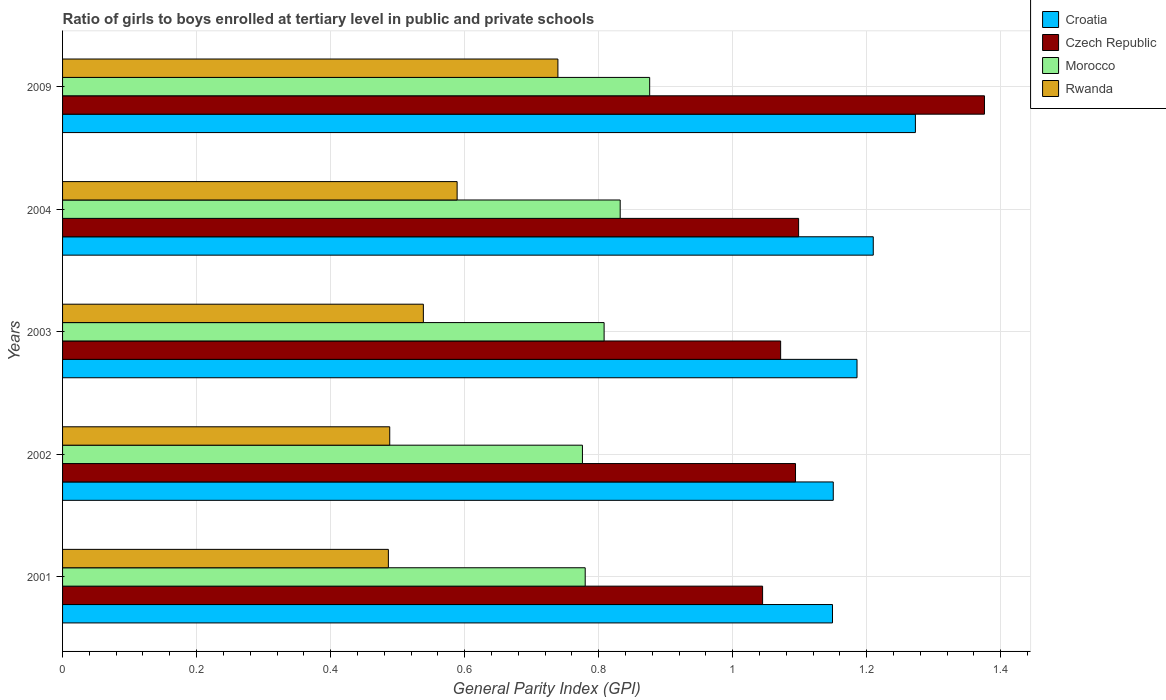How many groups of bars are there?
Offer a very short reply. 5. Are the number of bars on each tick of the Y-axis equal?
Provide a succinct answer. Yes. How many bars are there on the 4th tick from the top?
Your response must be concise. 4. How many bars are there on the 2nd tick from the bottom?
Provide a succinct answer. 4. What is the general parity index in Morocco in 2004?
Your answer should be very brief. 0.83. Across all years, what is the maximum general parity index in Czech Republic?
Give a very brief answer. 1.38. Across all years, what is the minimum general parity index in Croatia?
Make the answer very short. 1.15. What is the total general parity index in Morocco in the graph?
Provide a short and direct response. 4.07. What is the difference between the general parity index in Rwanda in 2003 and that in 2004?
Your answer should be compact. -0.05. What is the difference between the general parity index in Rwanda in 2001 and the general parity index in Croatia in 2003?
Your answer should be very brief. -0.7. What is the average general parity index in Morocco per year?
Make the answer very short. 0.81. In the year 2004, what is the difference between the general parity index in Morocco and general parity index in Croatia?
Make the answer very short. -0.38. What is the ratio of the general parity index in Czech Republic in 2003 to that in 2004?
Offer a very short reply. 0.98. What is the difference between the highest and the second highest general parity index in Morocco?
Your response must be concise. 0.04. What is the difference between the highest and the lowest general parity index in Morocco?
Your response must be concise. 0.1. Is it the case that in every year, the sum of the general parity index in Czech Republic and general parity index in Morocco is greater than the sum of general parity index in Croatia and general parity index in Rwanda?
Offer a very short reply. No. What does the 2nd bar from the top in 2009 represents?
Make the answer very short. Morocco. What does the 3rd bar from the bottom in 2003 represents?
Offer a very short reply. Morocco. How many bars are there?
Ensure brevity in your answer.  20. Are all the bars in the graph horizontal?
Offer a very short reply. Yes. What is the difference between two consecutive major ticks on the X-axis?
Offer a terse response. 0.2. Are the values on the major ticks of X-axis written in scientific E-notation?
Your answer should be compact. No. Does the graph contain any zero values?
Your response must be concise. No. Does the graph contain grids?
Provide a succinct answer. Yes. How many legend labels are there?
Give a very brief answer. 4. What is the title of the graph?
Offer a very short reply. Ratio of girls to boys enrolled at tertiary level in public and private schools. Does "Qatar" appear as one of the legend labels in the graph?
Provide a short and direct response. No. What is the label or title of the X-axis?
Your response must be concise. General Parity Index (GPI). What is the General Parity Index (GPI) in Croatia in 2001?
Provide a succinct answer. 1.15. What is the General Parity Index (GPI) in Czech Republic in 2001?
Provide a succinct answer. 1.04. What is the General Parity Index (GPI) in Morocco in 2001?
Your answer should be compact. 0.78. What is the General Parity Index (GPI) of Rwanda in 2001?
Your response must be concise. 0.49. What is the General Parity Index (GPI) of Croatia in 2002?
Offer a very short reply. 1.15. What is the General Parity Index (GPI) of Czech Republic in 2002?
Your answer should be compact. 1.09. What is the General Parity Index (GPI) of Morocco in 2002?
Offer a very short reply. 0.78. What is the General Parity Index (GPI) in Rwanda in 2002?
Your response must be concise. 0.49. What is the General Parity Index (GPI) in Croatia in 2003?
Ensure brevity in your answer.  1.19. What is the General Parity Index (GPI) in Czech Republic in 2003?
Offer a terse response. 1.07. What is the General Parity Index (GPI) of Morocco in 2003?
Your answer should be very brief. 0.81. What is the General Parity Index (GPI) in Rwanda in 2003?
Offer a very short reply. 0.54. What is the General Parity Index (GPI) in Croatia in 2004?
Your answer should be compact. 1.21. What is the General Parity Index (GPI) of Czech Republic in 2004?
Your answer should be compact. 1.1. What is the General Parity Index (GPI) of Morocco in 2004?
Provide a short and direct response. 0.83. What is the General Parity Index (GPI) in Rwanda in 2004?
Ensure brevity in your answer.  0.59. What is the General Parity Index (GPI) in Croatia in 2009?
Provide a succinct answer. 1.27. What is the General Parity Index (GPI) in Czech Republic in 2009?
Provide a succinct answer. 1.38. What is the General Parity Index (GPI) of Morocco in 2009?
Your answer should be compact. 0.88. What is the General Parity Index (GPI) in Rwanda in 2009?
Your response must be concise. 0.74. Across all years, what is the maximum General Parity Index (GPI) of Croatia?
Provide a short and direct response. 1.27. Across all years, what is the maximum General Parity Index (GPI) of Czech Republic?
Provide a short and direct response. 1.38. Across all years, what is the maximum General Parity Index (GPI) in Morocco?
Your response must be concise. 0.88. Across all years, what is the maximum General Parity Index (GPI) of Rwanda?
Provide a short and direct response. 0.74. Across all years, what is the minimum General Parity Index (GPI) in Croatia?
Your answer should be very brief. 1.15. Across all years, what is the minimum General Parity Index (GPI) in Czech Republic?
Ensure brevity in your answer.  1.04. Across all years, what is the minimum General Parity Index (GPI) of Morocco?
Your answer should be compact. 0.78. Across all years, what is the minimum General Parity Index (GPI) of Rwanda?
Offer a terse response. 0.49. What is the total General Parity Index (GPI) of Croatia in the graph?
Your answer should be compact. 5.97. What is the total General Parity Index (GPI) of Czech Republic in the graph?
Offer a terse response. 5.68. What is the total General Parity Index (GPI) of Morocco in the graph?
Ensure brevity in your answer.  4.07. What is the total General Parity Index (GPI) in Rwanda in the graph?
Your answer should be compact. 2.84. What is the difference between the General Parity Index (GPI) in Croatia in 2001 and that in 2002?
Your answer should be very brief. -0. What is the difference between the General Parity Index (GPI) in Czech Republic in 2001 and that in 2002?
Keep it short and to the point. -0.05. What is the difference between the General Parity Index (GPI) of Morocco in 2001 and that in 2002?
Ensure brevity in your answer.  0. What is the difference between the General Parity Index (GPI) in Rwanda in 2001 and that in 2002?
Provide a short and direct response. -0. What is the difference between the General Parity Index (GPI) of Croatia in 2001 and that in 2003?
Offer a terse response. -0.04. What is the difference between the General Parity Index (GPI) in Czech Republic in 2001 and that in 2003?
Make the answer very short. -0.03. What is the difference between the General Parity Index (GPI) of Morocco in 2001 and that in 2003?
Your answer should be compact. -0.03. What is the difference between the General Parity Index (GPI) of Rwanda in 2001 and that in 2003?
Ensure brevity in your answer.  -0.05. What is the difference between the General Parity Index (GPI) of Croatia in 2001 and that in 2004?
Your answer should be compact. -0.06. What is the difference between the General Parity Index (GPI) of Czech Republic in 2001 and that in 2004?
Ensure brevity in your answer.  -0.05. What is the difference between the General Parity Index (GPI) of Morocco in 2001 and that in 2004?
Offer a very short reply. -0.05. What is the difference between the General Parity Index (GPI) in Rwanda in 2001 and that in 2004?
Offer a very short reply. -0.1. What is the difference between the General Parity Index (GPI) in Croatia in 2001 and that in 2009?
Your answer should be very brief. -0.12. What is the difference between the General Parity Index (GPI) in Czech Republic in 2001 and that in 2009?
Ensure brevity in your answer.  -0.33. What is the difference between the General Parity Index (GPI) of Morocco in 2001 and that in 2009?
Offer a terse response. -0.1. What is the difference between the General Parity Index (GPI) in Rwanda in 2001 and that in 2009?
Keep it short and to the point. -0.25. What is the difference between the General Parity Index (GPI) of Croatia in 2002 and that in 2003?
Provide a short and direct response. -0.04. What is the difference between the General Parity Index (GPI) of Czech Republic in 2002 and that in 2003?
Give a very brief answer. 0.02. What is the difference between the General Parity Index (GPI) of Morocco in 2002 and that in 2003?
Your answer should be compact. -0.03. What is the difference between the General Parity Index (GPI) of Rwanda in 2002 and that in 2003?
Keep it short and to the point. -0.05. What is the difference between the General Parity Index (GPI) in Croatia in 2002 and that in 2004?
Ensure brevity in your answer.  -0.06. What is the difference between the General Parity Index (GPI) of Czech Republic in 2002 and that in 2004?
Provide a short and direct response. -0. What is the difference between the General Parity Index (GPI) in Morocco in 2002 and that in 2004?
Offer a terse response. -0.06. What is the difference between the General Parity Index (GPI) in Rwanda in 2002 and that in 2004?
Make the answer very short. -0.1. What is the difference between the General Parity Index (GPI) in Croatia in 2002 and that in 2009?
Make the answer very short. -0.12. What is the difference between the General Parity Index (GPI) of Czech Republic in 2002 and that in 2009?
Offer a very short reply. -0.28. What is the difference between the General Parity Index (GPI) in Morocco in 2002 and that in 2009?
Your answer should be very brief. -0.1. What is the difference between the General Parity Index (GPI) in Rwanda in 2002 and that in 2009?
Provide a succinct answer. -0.25. What is the difference between the General Parity Index (GPI) of Croatia in 2003 and that in 2004?
Ensure brevity in your answer.  -0.02. What is the difference between the General Parity Index (GPI) of Czech Republic in 2003 and that in 2004?
Provide a short and direct response. -0.03. What is the difference between the General Parity Index (GPI) in Morocco in 2003 and that in 2004?
Offer a terse response. -0.02. What is the difference between the General Parity Index (GPI) in Rwanda in 2003 and that in 2004?
Keep it short and to the point. -0.05. What is the difference between the General Parity Index (GPI) in Croatia in 2003 and that in 2009?
Give a very brief answer. -0.09. What is the difference between the General Parity Index (GPI) of Czech Republic in 2003 and that in 2009?
Your answer should be compact. -0.3. What is the difference between the General Parity Index (GPI) of Morocco in 2003 and that in 2009?
Your answer should be compact. -0.07. What is the difference between the General Parity Index (GPI) in Rwanda in 2003 and that in 2009?
Your answer should be compact. -0.2. What is the difference between the General Parity Index (GPI) in Croatia in 2004 and that in 2009?
Offer a very short reply. -0.06. What is the difference between the General Parity Index (GPI) in Czech Republic in 2004 and that in 2009?
Keep it short and to the point. -0.28. What is the difference between the General Parity Index (GPI) of Morocco in 2004 and that in 2009?
Your answer should be very brief. -0.04. What is the difference between the General Parity Index (GPI) in Rwanda in 2004 and that in 2009?
Provide a succinct answer. -0.15. What is the difference between the General Parity Index (GPI) in Croatia in 2001 and the General Parity Index (GPI) in Czech Republic in 2002?
Your response must be concise. 0.06. What is the difference between the General Parity Index (GPI) in Croatia in 2001 and the General Parity Index (GPI) in Morocco in 2002?
Offer a terse response. 0.37. What is the difference between the General Parity Index (GPI) in Croatia in 2001 and the General Parity Index (GPI) in Rwanda in 2002?
Keep it short and to the point. 0.66. What is the difference between the General Parity Index (GPI) of Czech Republic in 2001 and the General Parity Index (GPI) of Morocco in 2002?
Ensure brevity in your answer.  0.27. What is the difference between the General Parity Index (GPI) of Czech Republic in 2001 and the General Parity Index (GPI) of Rwanda in 2002?
Your answer should be very brief. 0.56. What is the difference between the General Parity Index (GPI) of Morocco in 2001 and the General Parity Index (GPI) of Rwanda in 2002?
Give a very brief answer. 0.29. What is the difference between the General Parity Index (GPI) of Croatia in 2001 and the General Parity Index (GPI) of Czech Republic in 2003?
Make the answer very short. 0.08. What is the difference between the General Parity Index (GPI) of Croatia in 2001 and the General Parity Index (GPI) of Morocco in 2003?
Provide a short and direct response. 0.34. What is the difference between the General Parity Index (GPI) in Croatia in 2001 and the General Parity Index (GPI) in Rwanda in 2003?
Keep it short and to the point. 0.61. What is the difference between the General Parity Index (GPI) of Czech Republic in 2001 and the General Parity Index (GPI) of Morocco in 2003?
Offer a very short reply. 0.24. What is the difference between the General Parity Index (GPI) of Czech Republic in 2001 and the General Parity Index (GPI) of Rwanda in 2003?
Offer a terse response. 0.51. What is the difference between the General Parity Index (GPI) of Morocco in 2001 and the General Parity Index (GPI) of Rwanda in 2003?
Your response must be concise. 0.24. What is the difference between the General Parity Index (GPI) in Croatia in 2001 and the General Parity Index (GPI) in Czech Republic in 2004?
Your answer should be very brief. 0.05. What is the difference between the General Parity Index (GPI) in Croatia in 2001 and the General Parity Index (GPI) in Morocco in 2004?
Give a very brief answer. 0.32. What is the difference between the General Parity Index (GPI) of Croatia in 2001 and the General Parity Index (GPI) of Rwanda in 2004?
Your response must be concise. 0.56. What is the difference between the General Parity Index (GPI) in Czech Republic in 2001 and the General Parity Index (GPI) in Morocco in 2004?
Provide a short and direct response. 0.21. What is the difference between the General Parity Index (GPI) in Czech Republic in 2001 and the General Parity Index (GPI) in Rwanda in 2004?
Your answer should be very brief. 0.46. What is the difference between the General Parity Index (GPI) in Morocco in 2001 and the General Parity Index (GPI) in Rwanda in 2004?
Provide a short and direct response. 0.19. What is the difference between the General Parity Index (GPI) of Croatia in 2001 and the General Parity Index (GPI) of Czech Republic in 2009?
Make the answer very short. -0.23. What is the difference between the General Parity Index (GPI) in Croatia in 2001 and the General Parity Index (GPI) in Morocco in 2009?
Provide a succinct answer. 0.27. What is the difference between the General Parity Index (GPI) of Croatia in 2001 and the General Parity Index (GPI) of Rwanda in 2009?
Give a very brief answer. 0.41. What is the difference between the General Parity Index (GPI) in Czech Republic in 2001 and the General Parity Index (GPI) in Morocco in 2009?
Keep it short and to the point. 0.17. What is the difference between the General Parity Index (GPI) in Czech Republic in 2001 and the General Parity Index (GPI) in Rwanda in 2009?
Ensure brevity in your answer.  0.31. What is the difference between the General Parity Index (GPI) in Morocco in 2001 and the General Parity Index (GPI) in Rwanda in 2009?
Offer a terse response. 0.04. What is the difference between the General Parity Index (GPI) in Croatia in 2002 and the General Parity Index (GPI) in Czech Republic in 2003?
Provide a short and direct response. 0.08. What is the difference between the General Parity Index (GPI) in Croatia in 2002 and the General Parity Index (GPI) in Morocco in 2003?
Your answer should be very brief. 0.34. What is the difference between the General Parity Index (GPI) of Croatia in 2002 and the General Parity Index (GPI) of Rwanda in 2003?
Your answer should be very brief. 0.61. What is the difference between the General Parity Index (GPI) of Czech Republic in 2002 and the General Parity Index (GPI) of Morocco in 2003?
Your answer should be compact. 0.29. What is the difference between the General Parity Index (GPI) of Czech Republic in 2002 and the General Parity Index (GPI) of Rwanda in 2003?
Provide a short and direct response. 0.56. What is the difference between the General Parity Index (GPI) of Morocco in 2002 and the General Parity Index (GPI) of Rwanda in 2003?
Make the answer very short. 0.24. What is the difference between the General Parity Index (GPI) in Croatia in 2002 and the General Parity Index (GPI) in Czech Republic in 2004?
Ensure brevity in your answer.  0.05. What is the difference between the General Parity Index (GPI) in Croatia in 2002 and the General Parity Index (GPI) in Morocco in 2004?
Your answer should be compact. 0.32. What is the difference between the General Parity Index (GPI) in Croatia in 2002 and the General Parity Index (GPI) in Rwanda in 2004?
Ensure brevity in your answer.  0.56. What is the difference between the General Parity Index (GPI) of Czech Republic in 2002 and the General Parity Index (GPI) of Morocco in 2004?
Provide a succinct answer. 0.26. What is the difference between the General Parity Index (GPI) in Czech Republic in 2002 and the General Parity Index (GPI) in Rwanda in 2004?
Provide a succinct answer. 0.51. What is the difference between the General Parity Index (GPI) in Morocco in 2002 and the General Parity Index (GPI) in Rwanda in 2004?
Make the answer very short. 0.19. What is the difference between the General Parity Index (GPI) in Croatia in 2002 and the General Parity Index (GPI) in Czech Republic in 2009?
Offer a terse response. -0.23. What is the difference between the General Parity Index (GPI) of Croatia in 2002 and the General Parity Index (GPI) of Morocco in 2009?
Offer a very short reply. 0.27. What is the difference between the General Parity Index (GPI) in Croatia in 2002 and the General Parity Index (GPI) in Rwanda in 2009?
Provide a short and direct response. 0.41. What is the difference between the General Parity Index (GPI) of Czech Republic in 2002 and the General Parity Index (GPI) of Morocco in 2009?
Your answer should be very brief. 0.22. What is the difference between the General Parity Index (GPI) of Czech Republic in 2002 and the General Parity Index (GPI) of Rwanda in 2009?
Your response must be concise. 0.35. What is the difference between the General Parity Index (GPI) of Morocco in 2002 and the General Parity Index (GPI) of Rwanda in 2009?
Give a very brief answer. 0.04. What is the difference between the General Parity Index (GPI) in Croatia in 2003 and the General Parity Index (GPI) in Czech Republic in 2004?
Make the answer very short. 0.09. What is the difference between the General Parity Index (GPI) of Croatia in 2003 and the General Parity Index (GPI) of Morocco in 2004?
Provide a succinct answer. 0.35. What is the difference between the General Parity Index (GPI) of Croatia in 2003 and the General Parity Index (GPI) of Rwanda in 2004?
Your answer should be compact. 0.6. What is the difference between the General Parity Index (GPI) in Czech Republic in 2003 and the General Parity Index (GPI) in Morocco in 2004?
Keep it short and to the point. 0.24. What is the difference between the General Parity Index (GPI) in Czech Republic in 2003 and the General Parity Index (GPI) in Rwanda in 2004?
Provide a succinct answer. 0.48. What is the difference between the General Parity Index (GPI) of Morocco in 2003 and the General Parity Index (GPI) of Rwanda in 2004?
Your answer should be compact. 0.22. What is the difference between the General Parity Index (GPI) of Croatia in 2003 and the General Parity Index (GPI) of Czech Republic in 2009?
Ensure brevity in your answer.  -0.19. What is the difference between the General Parity Index (GPI) in Croatia in 2003 and the General Parity Index (GPI) in Morocco in 2009?
Your answer should be very brief. 0.31. What is the difference between the General Parity Index (GPI) of Croatia in 2003 and the General Parity Index (GPI) of Rwanda in 2009?
Offer a very short reply. 0.45. What is the difference between the General Parity Index (GPI) in Czech Republic in 2003 and the General Parity Index (GPI) in Morocco in 2009?
Your answer should be very brief. 0.2. What is the difference between the General Parity Index (GPI) of Czech Republic in 2003 and the General Parity Index (GPI) of Rwanda in 2009?
Provide a succinct answer. 0.33. What is the difference between the General Parity Index (GPI) in Morocco in 2003 and the General Parity Index (GPI) in Rwanda in 2009?
Offer a terse response. 0.07. What is the difference between the General Parity Index (GPI) in Croatia in 2004 and the General Parity Index (GPI) in Czech Republic in 2009?
Give a very brief answer. -0.17. What is the difference between the General Parity Index (GPI) of Croatia in 2004 and the General Parity Index (GPI) of Morocco in 2009?
Your answer should be very brief. 0.33. What is the difference between the General Parity Index (GPI) of Croatia in 2004 and the General Parity Index (GPI) of Rwanda in 2009?
Your response must be concise. 0.47. What is the difference between the General Parity Index (GPI) in Czech Republic in 2004 and the General Parity Index (GPI) in Morocco in 2009?
Ensure brevity in your answer.  0.22. What is the difference between the General Parity Index (GPI) of Czech Republic in 2004 and the General Parity Index (GPI) of Rwanda in 2009?
Provide a succinct answer. 0.36. What is the difference between the General Parity Index (GPI) of Morocco in 2004 and the General Parity Index (GPI) of Rwanda in 2009?
Make the answer very short. 0.09. What is the average General Parity Index (GPI) of Croatia per year?
Keep it short and to the point. 1.19. What is the average General Parity Index (GPI) in Czech Republic per year?
Your answer should be very brief. 1.14. What is the average General Parity Index (GPI) of Morocco per year?
Provide a short and direct response. 0.81. What is the average General Parity Index (GPI) in Rwanda per year?
Offer a very short reply. 0.57. In the year 2001, what is the difference between the General Parity Index (GPI) in Croatia and General Parity Index (GPI) in Czech Republic?
Offer a terse response. 0.1. In the year 2001, what is the difference between the General Parity Index (GPI) of Croatia and General Parity Index (GPI) of Morocco?
Ensure brevity in your answer.  0.37. In the year 2001, what is the difference between the General Parity Index (GPI) in Croatia and General Parity Index (GPI) in Rwanda?
Keep it short and to the point. 0.66. In the year 2001, what is the difference between the General Parity Index (GPI) in Czech Republic and General Parity Index (GPI) in Morocco?
Provide a succinct answer. 0.26. In the year 2001, what is the difference between the General Parity Index (GPI) in Czech Republic and General Parity Index (GPI) in Rwanda?
Your response must be concise. 0.56. In the year 2001, what is the difference between the General Parity Index (GPI) in Morocco and General Parity Index (GPI) in Rwanda?
Your answer should be very brief. 0.29. In the year 2002, what is the difference between the General Parity Index (GPI) in Croatia and General Parity Index (GPI) in Czech Republic?
Provide a short and direct response. 0.06. In the year 2002, what is the difference between the General Parity Index (GPI) of Croatia and General Parity Index (GPI) of Morocco?
Your answer should be very brief. 0.37. In the year 2002, what is the difference between the General Parity Index (GPI) of Croatia and General Parity Index (GPI) of Rwanda?
Your answer should be very brief. 0.66. In the year 2002, what is the difference between the General Parity Index (GPI) of Czech Republic and General Parity Index (GPI) of Morocco?
Provide a short and direct response. 0.32. In the year 2002, what is the difference between the General Parity Index (GPI) of Czech Republic and General Parity Index (GPI) of Rwanda?
Give a very brief answer. 0.61. In the year 2002, what is the difference between the General Parity Index (GPI) of Morocco and General Parity Index (GPI) of Rwanda?
Provide a short and direct response. 0.29. In the year 2003, what is the difference between the General Parity Index (GPI) in Croatia and General Parity Index (GPI) in Czech Republic?
Ensure brevity in your answer.  0.11. In the year 2003, what is the difference between the General Parity Index (GPI) of Croatia and General Parity Index (GPI) of Morocco?
Keep it short and to the point. 0.38. In the year 2003, what is the difference between the General Parity Index (GPI) in Croatia and General Parity Index (GPI) in Rwanda?
Keep it short and to the point. 0.65. In the year 2003, what is the difference between the General Parity Index (GPI) in Czech Republic and General Parity Index (GPI) in Morocco?
Provide a short and direct response. 0.26. In the year 2003, what is the difference between the General Parity Index (GPI) of Czech Republic and General Parity Index (GPI) of Rwanda?
Offer a very short reply. 0.53. In the year 2003, what is the difference between the General Parity Index (GPI) of Morocco and General Parity Index (GPI) of Rwanda?
Offer a very short reply. 0.27. In the year 2004, what is the difference between the General Parity Index (GPI) in Croatia and General Parity Index (GPI) in Czech Republic?
Make the answer very short. 0.11. In the year 2004, what is the difference between the General Parity Index (GPI) of Croatia and General Parity Index (GPI) of Morocco?
Offer a very short reply. 0.38. In the year 2004, what is the difference between the General Parity Index (GPI) in Croatia and General Parity Index (GPI) in Rwanda?
Provide a succinct answer. 0.62. In the year 2004, what is the difference between the General Parity Index (GPI) of Czech Republic and General Parity Index (GPI) of Morocco?
Your answer should be compact. 0.27. In the year 2004, what is the difference between the General Parity Index (GPI) of Czech Republic and General Parity Index (GPI) of Rwanda?
Provide a short and direct response. 0.51. In the year 2004, what is the difference between the General Parity Index (GPI) of Morocco and General Parity Index (GPI) of Rwanda?
Your response must be concise. 0.24. In the year 2009, what is the difference between the General Parity Index (GPI) in Croatia and General Parity Index (GPI) in Czech Republic?
Provide a succinct answer. -0.1. In the year 2009, what is the difference between the General Parity Index (GPI) of Croatia and General Parity Index (GPI) of Morocco?
Your answer should be compact. 0.4. In the year 2009, what is the difference between the General Parity Index (GPI) in Croatia and General Parity Index (GPI) in Rwanda?
Provide a short and direct response. 0.53. In the year 2009, what is the difference between the General Parity Index (GPI) of Czech Republic and General Parity Index (GPI) of Morocco?
Make the answer very short. 0.5. In the year 2009, what is the difference between the General Parity Index (GPI) of Czech Republic and General Parity Index (GPI) of Rwanda?
Provide a succinct answer. 0.64. In the year 2009, what is the difference between the General Parity Index (GPI) of Morocco and General Parity Index (GPI) of Rwanda?
Your response must be concise. 0.14. What is the ratio of the General Parity Index (GPI) in Czech Republic in 2001 to that in 2002?
Keep it short and to the point. 0.96. What is the ratio of the General Parity Index (GPI) of Morocco in 2001 to that in 2002?
Your answer should be compact. 1.01. What is the ratio of the General Parity Index (GPI) of Rwanda in 2001 to that in 2002?
Ensure brevity in your answer.  1. What is the ratio of the General Parity Index (GPI) of Croatia in 2001 to that in 2003?
Ensure brevity in your answer.  0.97. What is the ratio of the General Parity Index (GPI) of Czech Republic in 2001 to that in 2003?
Make the answer very short. 0.97. What is the ratio of the General Parity Index (GPI) of Morocco in 2001 to that in 2003?
Make the answer very short. 0.97. What is the ratio of the General Parity Index (GPI) in Rwanda in 2001 to that in 2003?
Offer a very short reply. 0.9. What is the ratio of the General Parity Index (GPI) in Croatia in 2001 to that in 2004?
Give a very brief answer. 0.95. What is the ratio of the General Parity Index (GPI) in Czech Republic in 2001 to that in 2004?
Your response must be concise. 0.95. What is the ratio of the General Parity Index (GPI) of Morocco in 2001 to that in 2004?
Give a very brief answer. 0.94. What is the ratio of the General Parity Index (GPI) of Rwanda in 2001 to that in 2004?
Your answer should be compact. 0.83. What is the ratio of the General Parity Index (GPI) in Croatia in 2001 to that in 2009?
Your response must be concise. 0.9. What is the ratio of the General Parity Index (GPI) of Czech Republic in 2001 to that in 2009?
Give a very brief answer. 0.76. What is the ratio of the General Parity Index (GPI) of Morocco in 2001 to that in 2009?
Your answer should be compact. 0.89. What is the ratio of the General Parity Index (GPI) in Rwanda in 2001 to that in 2009?
Make the answer very short. 0.66. What is the ratio of the General Parity Index (GPI) of Croatia in 2002 to that in 2003?
Provide a succinct answer. 0.97. What is the ratio of the General Parity Index (GPI) in Czech Republic in 2002 to that in 2003?
Make the answer very short. 1.02. What is the ratio of the General Parity Index (GPI) in Morocco in 2002 to that in 2003?
Your response must be concise. 0.96. What is the ratio of the General Parity Index (GPI) of Rwanda in 2002 to that in 2003?
Ensure brevity in your answer.  0.91. What is the ratio of the General Parity Index (GPI) of Croatia in 2002 to that in 2004?
Provide a short and direct response. 0.95. What is the ratio of the General Parity Index (GPI) in Morocco in 2002 to that in 2004?
Your answer should be very brief. 0.93. What is the ratio of the General Parity Index (GPI) of Rwanda in 2002 to that in 2004?
Provide a succinct answer. 0.83. What is the ratio of the General Parity Index (GPI) of Croatia in 2002 to that in 2009?
Give a very brief answer. 0.9. What is the ratio of the General Parity Index (GPI) in Czech Republic in 2002 to that in 2009?
Provide a short and direct response. 0.8. What is the ratio of the General Parity Index (GPI) of Morocco in 2002 to that in 2009?
Provide a succinct answer. 0.89. What is the ratio of the General Parity Index (GPI) of Rwanda in 2002 to that in 2009?
Keep it short and to the point. 0.66. What is the ratio of the General Parity Index (GPI) in Czech Republic in 2003 to that in 2004?
Keep it short and to the point. 0.98. What is the ratio of the General Parity Index (GPI) in Morocco in 2003 to that in 2004?
Keep it short and to the point. 0.97. What is the ratio of the General Parity Index (GPI) of Rwanda in 2003 to that in 2004?
Offer a very short reply. 0.91. What is the ratio of the General Parity Index (GPI) of Croatia in 2003 to that in 2009?
Your answer should be compact. 0.93. What is the ratio of the General Parity Index (GPI) of Czech Republic in 2003 to that in 2009?
Make the answer very short. 0.78. What is the ratio of the General Parity Index (GPI) in Morocco in 2003 to that in 2009?
Provide a succinct answer. 0.92. What is the ratio of the General Parity Index (GPI) of Rwanda in 2003 to that in 2009?
Provide a succinct answer. 0.73. What is the ratio of the General Parity Index (GPI) in Croatia in 2004 to that in 2009?
Your response must be concise. 0.95. What is the ratio of the General Parity Index (GPI) of Czech Republic in 2004 to that in 2009?
Your answer should be very brief. 0.8. What is the ratio of the General Parity Index (GPI) in Morocco in 2004 to that in 2009?
Offer a terse response. 0.95. What is the ratio of the General Parity Index (GPI) in Rwanda in 2004 to that in 2009?
Keep it short and to the point. 0.8. What is the difference between the highest and the second highest General Parity Index (GPI) of Croatia?
Provide a succinct answer. 0.06. What is the difference between the highest and the second highest General Parity Index (GPI) in Czech Republic?
Keep it short and to the point. 0.28. What is the difference between the highest and the second highest General Parity Index (GPI) of Morocco?
Offer a terse response. 0.04. What is the difference between the highest and the second highest General Parity Index (GPI) of Rwanda?
Offer a very short reply. 0.15. What is the difference between the highest and the lowest General Parity Index (GPI) of Croatia?
Your answer should be compact. 0.12. What is the difference between the highest and the lowest General Parity Index (GPI) in Czech Republic?
Your answer should be compact. 0.33. What is the difference between the highest and the lowest General Parity Index (GPI) of Morocco?
Ensure brevity in your answer.  0.1. What is the difference between the highest and the lowest General Parity Index (GPI) in Rwanda?
Keep it short and to the point. 0.25. 